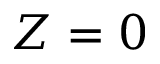Convert formula to latex. <formula><loc_0><loc_0><loc_500><loc_500>Z = 0</formula> 